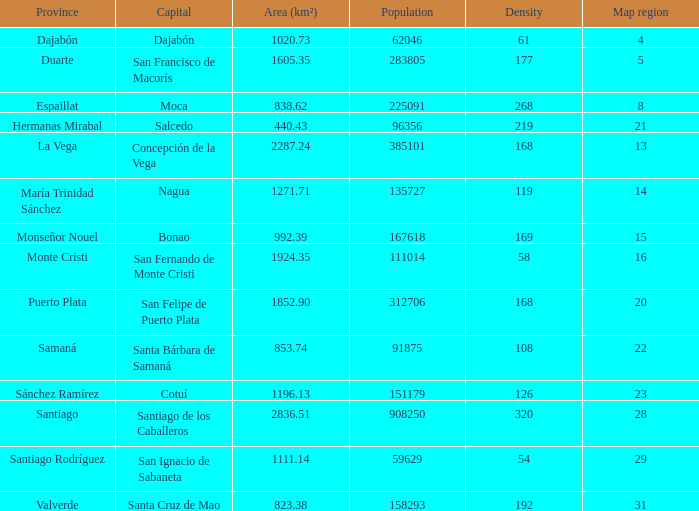35 km², how many provinces are present? 1.0. 